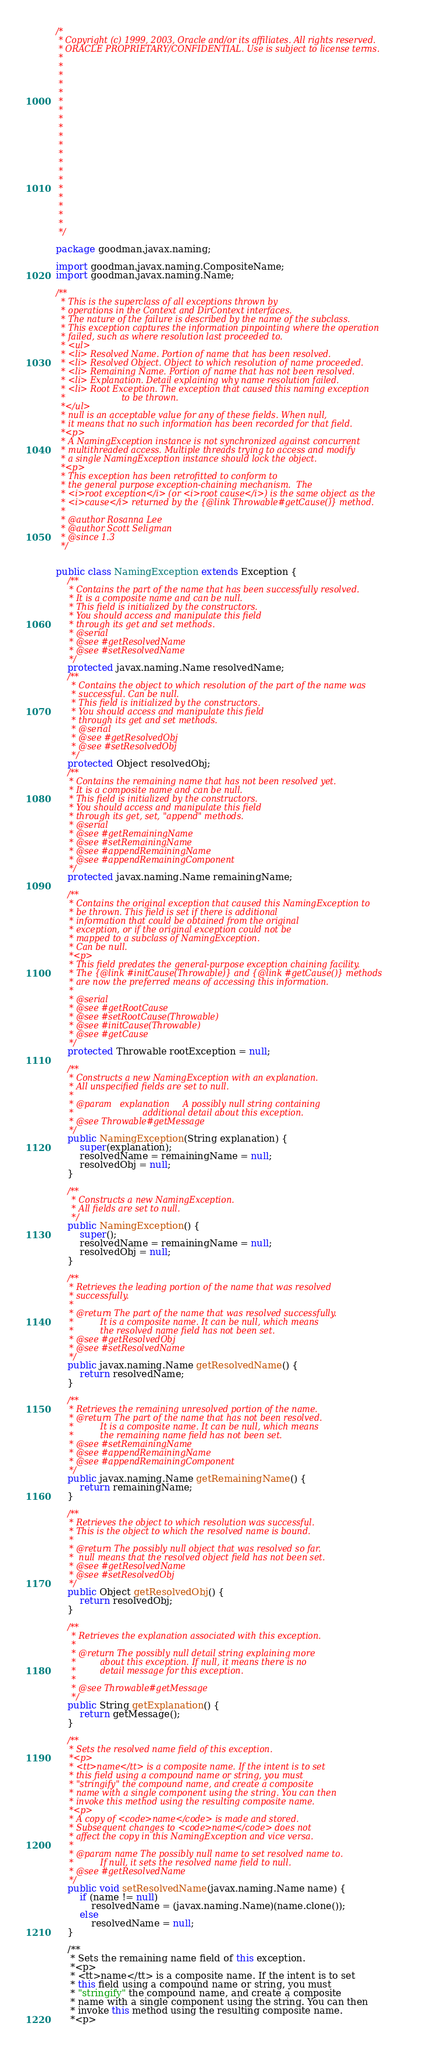Convert code to text. <code><loc_0><loc_0><loc_500><loc_500><_Java_>/*
 * Copyright (c) 1999, 2003, Oracle and/or its affiliates. All rights reserved.
 * ORACLE PROPRIETARY/CONFIDENTIAL. Use is subject to license terms.
 *
 *
 *
 *
 *
 *
 *
 *
 *
 *
 *
 *
 *
 *
 *
 *
 *
 *
 *
 *
 */

package goodman.javax.naming;

import goodman.javax.naming.CompositeName;
import goodman.javax.naming.Name;

/**
  * This is the superclass of all exceptions thrown by
  * operations in the Context and DirContext interfaces.
  * The nature of the failure is described by the name of the subclass.
  * This exception captures the information pinpointing where the operation
  * failed, such as where resolution last proceeded to.
  * <ul>
  * <li> Resolved Name. Portion of name that has been resolved.
  * <li> Resolved Object. Object to which resolution of name proceeded.
  * <li> Remaining Name. Portion of name that has not been resolved.
  * <li> Explanation. Detail explaining why name resolution failed.
  * <li> Root Exception. The exception that caused this naming exception
  *                     to be thrown.
  *</ul>
  * null is an acceptable value for any of these fields. When null,
  * it means that no such information has been recorded for that field.
  *<p>
  * A NamingException instance is not synchronized against concurrent
  * multithreaded access. Multiple threads trying to access and modify
  * a single NamingException instance should lock the object.
  *<p>
  * This exception has been retrofitted to conform to
  * the general purpose exception-chaining mechanism.  The
  * <i>root exception</i> (or <i>root cause</i>) is the same object as the
  * <i>cause</i> returned by the {@link Throwable#getCause()} method.
  *
  * @author Rosanna Lee
  * @author Scott Seligman
  * @since 1.3
  */


public class NamingException extends Exception {
    /**
     * Contains the part of the name that has been successfully resolved.
     * It is a composite name and can be null.
     * This field is initialized by the constructors.
     * You should access and manipulate this field
     * through its get and set methods.
     * @serial
     * @see #getResolvedName
     * @see #setResolvedName
     */
    protected javax.naming.Name resolvedName;
    /**
      * Contains the object to which resolution of the part of the name was
      * successful. Can be null.
      * This field is initialized by the constructors.
      * You should access and manipulate this field
      * through its get and set methods.
      * @serial
      * @see #getResolvedObj
      * @see #setResolvedObj
      */
    protected Object resolvedObj;
    /**
     * Contains the remaining name that has not been resolved yet.
     * It is a composite name and can be null.
     * This field is initialized by the constructors.
     * You should access and manipulate this field
     * through its get, set, "append" methods.
     * @serial
     * @see #getRemainingName
     * @see #setRemainingName
     * @see #appendRemainingName
     * @see #appendRemainingComponent
     */
    protected javax.naming.Name remainingName;

    /**
     * Contains the original exception that caused this NamingException to
     * be thrown. This field is set if there is additional
     * information that could be obtained from the original
     * exception, or if the original exception could not be
     * mapped to a subclass of NamingException.
     * Can be null.
     *<p>
     * This field predates the general-purpose exception chaining facility.
     * The {@link #initCause(Throwable)} and {@link #getCause()} methods
     * are now the preferred means of accessing this information.
     *
     * @serial
     * @see #getRootCause
     * @see #setRootCause(Throwable)
     * @see #initCause(Throwable)
     * @see #getCause
     */
    protected Throwable rootException = null;

    /**
     * Constructs a new NamingException with an explanation.
     * All unspecified fields are set to null.
     *
     * @param   explanation     A possibly null string containing
     *                          additional detail about this exception.
     * @see Throwable#getMessage
     */
    public NamingException(String explanation) {
        super(explanation);
        resolvedName = remainingName = null;
        resolvedObj = null;
    }

    /**
      * Constructs a new NamingException.
      * All fields are set to null.
      */
    public NamingException() {
        super();
        resolvedName = remainingName = null;
        resolvedObj = null;
    }

    /**
     * Retrieves the leading portion of the name that was resolved
     * successfully.
     *
     * @return The part of the name that was resolved successfully.
     *          It is a composite name. It can be null, which means
     *          the resolved name field has not been set.
     * @see #getResolvedObj
     * @see #setResolvedName
     */
    public javax.naming.Name getResolvedName() {
        return resolvedName;
    }

    /**
     * Retrieves the remaining unresolved portion of the name.
     * @return The part of the name that has not been resolved.
     *          It is a composite name. It can be null, which means
     *          the remaining name field has not been set.
     * @see #setRemainingName
     * @see #appendRemainingName
     * @see #appendRemainingComponent
     */
    public javax.naming.Name getRemainingName() {
        return remainingName;
    }

    /**
     * Retrieves the object to which resolution was successful.
     * This is the object to which the resolved name is bound.
     *
     * @return The possibly null object that was resolved so far.
     *  null means that the resolved object field has not been set.
     * @see #getResolvedName
     * @see #setResolvedObj
     */
    public Object getResolvedObj() {
        return resolvedObj;
    }

    /**
      * Retrieves the explanation associated with this exception.
      *
      * @return The possibly null detail string explaining more
      *         about this exception. If null, it means there is no
      *         detail message for this exception.
      *
      * @see Throwable#getMessage
      */
    public String getExplanation() {
        return getMessage();
    }

    /**
     * Sets the resolved name field of this exception.
     *<p>
     * <tt>name</tt> is a composite name. If the intent is to set
     * this field using a compound name or string, you must
     * "stringify" the compound name, and create a composite
     * name with a single component using the string. You can then
     * invoke this method using the resulting composite name.
     *<p>
     * A copy of <code>name</code> is made and stored.
     * Subsequent changes to <code>name</code> does not
     * affect the copy in this NamingException and vice versa.
     *
     * @param name The possibly null name to set resolved name to.
     *          If null, it sets the resolved name field to null.
     * @see #getResolvedName
     */
    public void setResolvedName(javax.naming.Name name) {
        if (name != null)
            resolvedName = (javax.naming.Name)(name.clone());
        else
            resolvedName = null;
    }

    /**
     * Sets the remaining name field of this exception.
     *<p>
     * <tt>name</tt> is a composite name. If the intent is to set
     * this field using a compound name or string, you must
     * "stringify" the compound name, and create a composite
     * name with a single component using the string. You can then
     * invoke this method using the resulting composite name.
     *<p></code> 